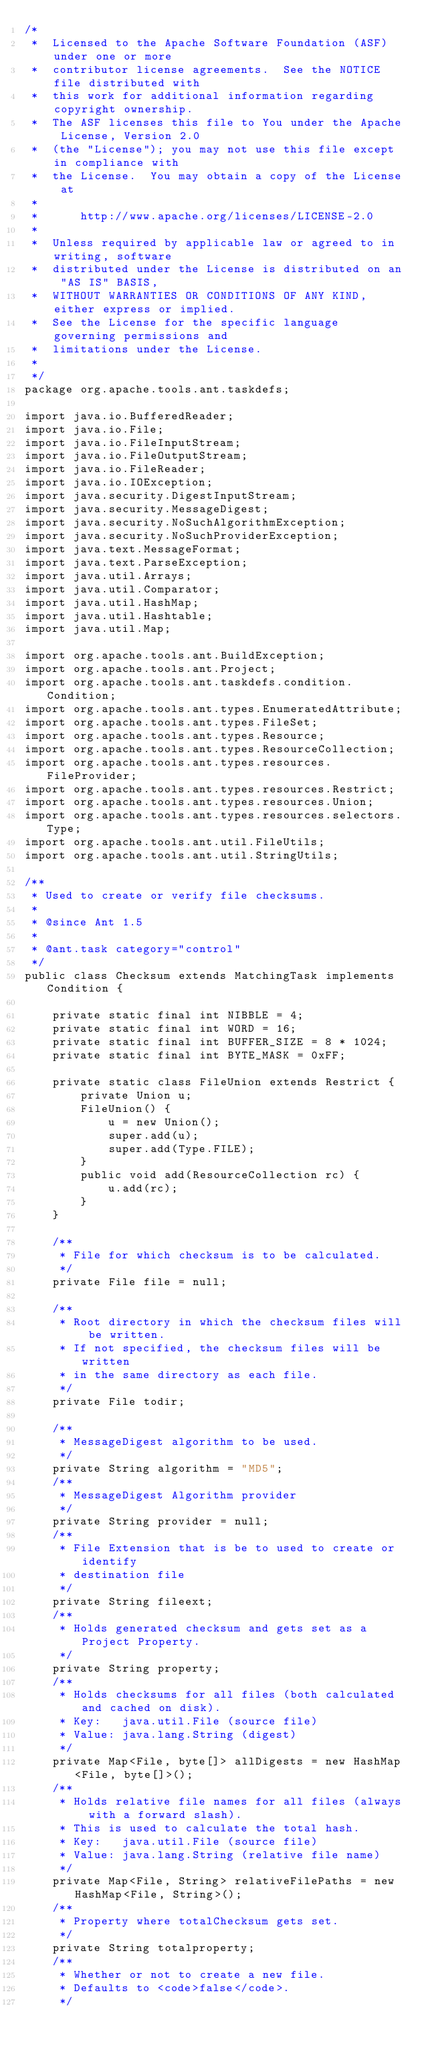<code> <loc_0><loc_0><loc_500><loc_500><_Java_>/*
 *  Licensed to the Apache Software Foundation (ASF) under one or more
 *  contributor license agreements.  See the NOTICE file distributed with
 *  this work for additional information regarding copyright ownership.
 *  The ASF licenses this file to You under the Apache License, Version 2.0
 *  (the "License"); you may not use this file except in compliance with
 *  the License.  You may obtain a copy of the License at
 *
 *      http://www.apache.org/licenses/LICENSE-2.0
 *
 *  Unless required by applicable law or agreed to in writing, software
 *  distributed under the License is distributed on an "AS IS" BASIS,
 *  WITHOUT WARRANTIES OR CONDITIONS OF ANY KIND, either express or implied.
 *  See the License for the specific language governing permissions and
 *  limitations under the License.
 *
 */
package org.apache.tools.ant.taskdefs;

import java.io.BufferedReader;
import java.io.File;
import java.io.FileInputStream;
import java.io.FileOutputStream;
import java.io.FileReader;
import java.io.IOException;
import java.security.DigestInputStream;
import java.security.MessageDigest;
import java.security.NoSuchAlgorithmException;
import java.security.NoSuchProviderException;
import java.text.MessageFormat;
import java.text.ParseException;
import java.util.Arrays;
import java.util.Comparator;
import java.util.HashMap;
import java.util.Hashtable;
import java.util.Map;

import org.apache.tools.ant.BuildException;
import org.apache.tools.ant.Project;
import org.apache.tools.ant.taskdefs.condition.Condition;
import org.apache.tools.ant.types.EnumeratedAttribute;
import org.apache.tools.ant.types.FileSet;
import org.apache.tools.ant.types.Resource;
import org.apache.tools.ant.types.ResourceCollection;
import org.apache.tools.ant.types.resources.FileProvider;
import org.apache.tools.ant.types.resources.Restrict;
import org.apache.tools.ant.types.resources.Union;
import org.apache.tools.ant.types.resources.selectors.Type;
import org.apache.tools.ant.util.FileUtils;
import org.apache.tools.ant.util.StringUtils;

/**
 * Used to create or verify file checksums.
 *
 * @since Ant 1.5
 *
 * @ant.task category="control"
 */
public class Checksum extends MatchingTask implements Condition {

    private static final int NIBBLE = 4;
    private static final int WORD = 16;
    private static final int BUFFER_SIZE = 8 * 1024;
    private static final int BYTE_MASK = 0xFF;

    private static class FileUnion extends Restrict {
        private Union u;
        FileUnion() {
            u = new Union();
            super.add(u);
            super.add(Type.FILE);
        }
        public void add(ResourceCollection rc) {
            u.add(rc);
        }
    }

    /**
     * File for which checksum is to be calculated.
     */
    private File file = null;

    /**
     * Root directory in which the checksum files will be written.
     * If not specified, the checksum files will be written
     * in the same directory as each file.
     */
    private File todir;

    /**
     * MessageDigest algorithm to be used.
     */
    private String algorithm = "MD5";
    /**
     * MessageDigest Algorithm provider
     */
    private String provider = null;
    /**
     * File Extension that is be to used to create or identify
     * destination file
     */
    private String fileext;
    /**
     * Holds generated checksum and gets set as a Project Property.
     */
    private String property;
    /**
     * Holds checksums for all files (both calculated and cached on disk).
     * Key:   java.util.File (source file)
     * Value: java.lang.String (digest)
     */
    private Map<File, byte[]> allDigests = new HashMap<File, byte[]>();
    /**
     * Holds relative file names for all files (always with a forward slash).
     * This is used to calculate the total hash.
     * Key:   java.util.File (source file)
     * Value: java.lang.String (relative file name)
     */
    private Map<File, String> relativeFilePaths = new HashMap<File, String>();
    /**
     * Property where totalChecksum gets set.
     */
    private String totalproperty;
    /**
     * Whether or not to create a new file.
     * Defaults to <code>false</code>.
     */</code> 